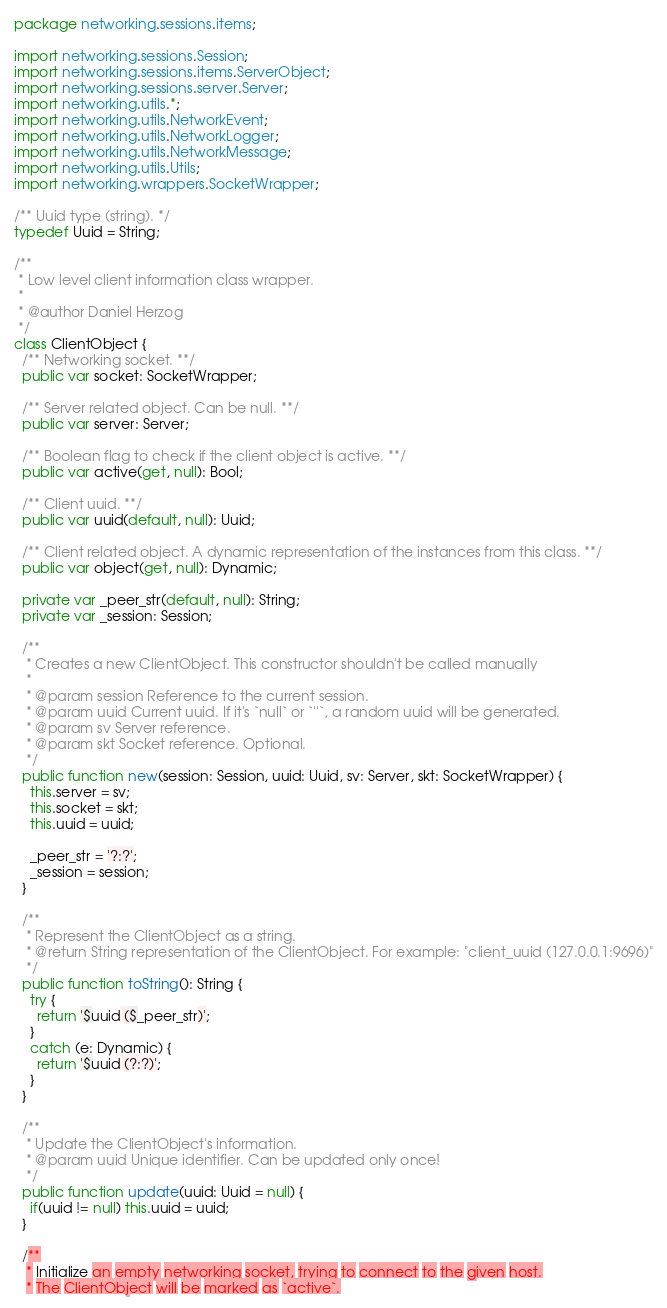Convert code to text. <code><loc_0><loc_0><loc_500><loc_500><_Haxe_>package networking.sessions.items;

import networking.sessions.Session;
import networking.sessions.items.ServerObject;
import networking.sessions.server.Server;
import networking.utils.*;
import networking.utils.NetworkEvent;
import networking.utils.NetworkLogger;
import networking.utils.NetworkMessage;
import networking.utils.Utils;
import networking.wrappers.SocketWrapper;

/** Uuid type (string). */
typedef Uuid = String;

/**
 * Low level client information class wrapper.
 *
 * @author Daniel Herzog
 */
class ClientObject {
  /** Networking socket. **/
  public var socket: SocketWrapper;

  /** Server related object. Can be null. **/
  public var server: Server;

  /** Boolean flag to check if the client object is active. **/
  public var active(get, null): Bool;

  /** Client uuid. **/
  public var uuid(default, null): Uuid;

  /** Client related object. A dynamic representation of the instances from this class. **/
  public var object(get, null): Dynamic;

  private var _peer_str(default, null): String;
  private var _session: Session;

  /**
   * Creates a new ClientObject. This constructor shouldn't be called manually
   *
   * @param session Reference to the current session.
   * @param uuid Current uuid. If it's `null` or `''`, a random uuid will be generated.
   * @param sv Server reference.
   * @param skt Socket reference. Optional.
   */
  public function new(session: Session, uuid: Uuid, sv: Server, skt: SocketWrapper) {
    this.server = sv;
    this.socket = skt;
    this.uuid = uuid;

    _peer_str = '?:?';
    _session = session;
  }

  /**
   * Represent the ClientObject as a string.
   * @return String representation of the ClientObject. For example: "client_uuid (127.0.0.1:9696)"
   */
  public function toString(): String {
    try {
      return '$uuid ($_peer_str)';
    }
    catch (e: Dynamic) {
      return '$uuid (?:?)';
    }
  }

  /**
   * Update the ClientObject's information.
   * @param uuid Unique identifier. Can be updated only once!
   */
  public function update(uuid: Uuid = null) {
    if(uuid != null) this.uuid = uuid;
  }

  /**
   * Initialize an empty networking socket, trying to connect to the given host.
   * The ClientObject will be marked as `active`.</code> 